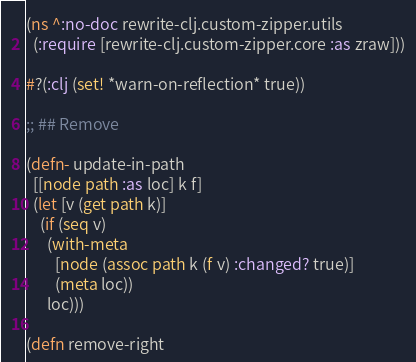Convert code to text. <code><loc_0><loc_0><loc_500><loc_500><_Clojure_>(ns ^:no-doc rewrite-clj.custom-zipper.utils
  (:require [rewrite-clj.custom-zipper.core :as zraw]))

#?(:clj (set! *warn-on-reflection* true))

;; ## Remove

(defn- update-in-path
  [[node path :as loc] k f]
  (let [v (get path k)]
    (if (seq v)
      (with-meta
        [node (assoc path k (f v) :changed? true)]
        (meta loc))
      loc)))

(defn remove-right</code> 